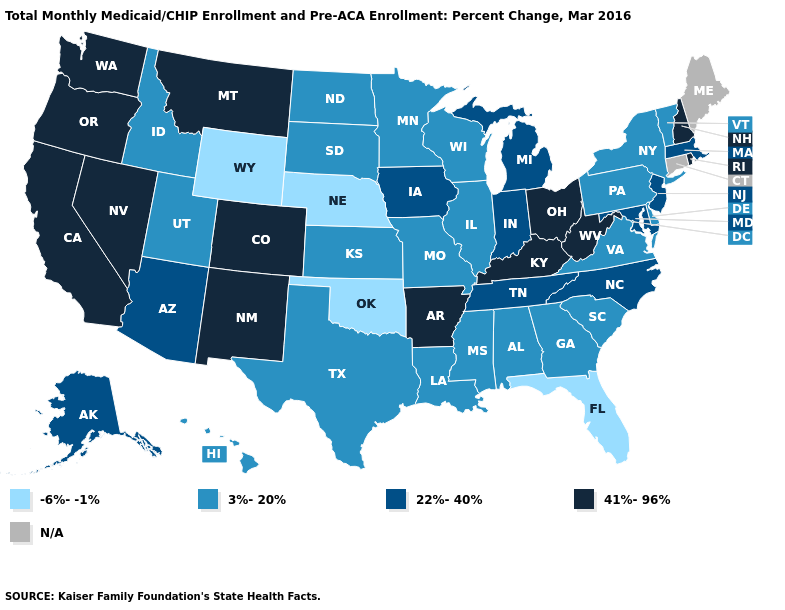Which states have the lowest value in the USA?
Concise answer only. Florida, Nebraska, Oklahoma, Wyoming. Does Nebraska have the lowest value in the MidWest?
Be succinct. Yes. Name the states that have a value in the range 41%-96%?
Be succinct. Arkansas, California, Colorado, Kentucky, Montana, Nevada, New Hampshire, New Mexico, Ohio, Oregon, Rhode Island, Washington, West Virginia. What is the value of Alabama?
Be succinct. 3%-20%. Name the states that have a value in the range N/A?
Give a very brief answer. Connecticut, Maine. Does Rhode Island have the highest value in the Northeast?
Give a very brief answer. Yes. What is the value of Maryland?
Give a very brief answer. 22%-40%. Name the states that have a value in the range 22%-40%?
Answer briefly. Alaska, Arizona, Indiana, Iowa, Maryland, Massachusetts, Michigan, New Jersey, North Carolina, Tennessee. Among the states that border Florida , which have the highest value?
Give a very brief answer. Alabama, Georgia. What is the lowest value in the USA?
Write a very short answer. -6%--1%. What is the value of Minnesota?
Short answer required. 3%-20%. Name the states that have a value in the range 22%-40%?
Keep it brief. Alaska, Arizona, Indiana, Iowa, Maryland, Massachusetts, Michigan, New Jersey, North Carolina, Tennessee. What is the value of New Mexico?
Answer briefly. 41%-96%. Name the states that have a value in the range N/A?
Concise answer only. Connecticut, Maine. What is the value of Oklahoma?
Give a very brief answer. -6%--1%. 